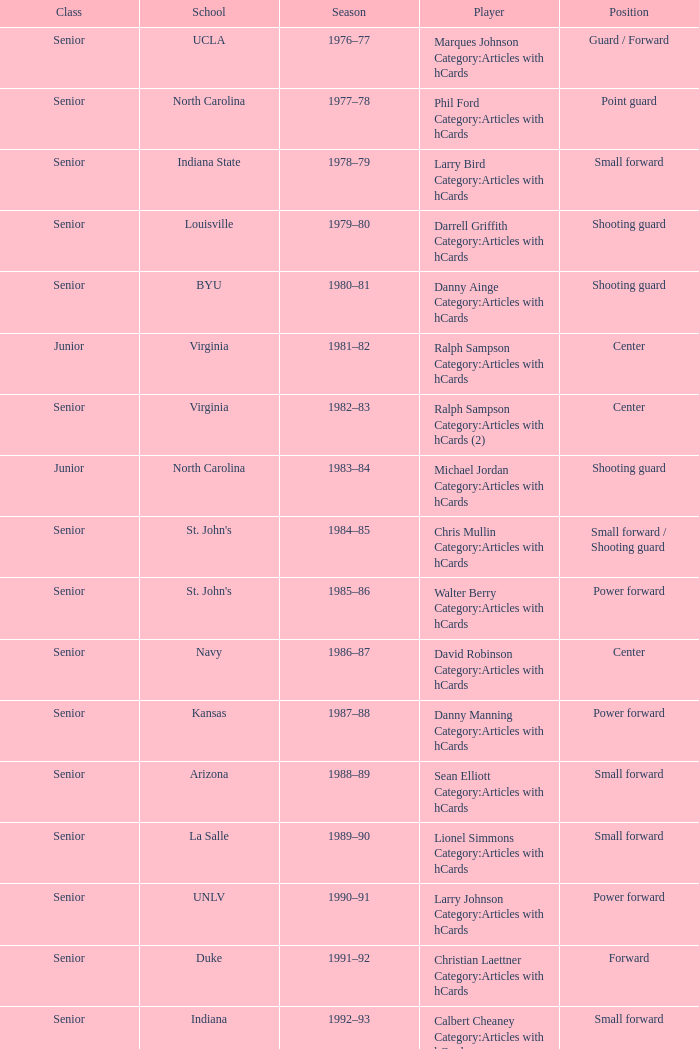Can you parse all the data within this table? {'header': ['Class', 'School', 'Season', 'Player', 'Position'], 'rows': [['Senior', 'UCLA', '1976–77', 'Marques Johnson Category:Articles with hCards', 'Guard / Forward'], ['Senior', 'North Carolina', '1977–78', 'Phil Ford Category:Articles with hCards', 'Point guard'], ['Senior', 'Indiana State', '1978–79', 'Larry Bird Category:Articles with hCards', 'Small forward'], ['Senior', 'Louisville', '1979–80', 'Darrell Griffith Category:Articles with hCards', 'Shooting guard'], ['Senior', 'BYU', '1980–81', 'Danny Ainge Category:Articles with hCards', 'Shooting guard'], ['Junior', 'Virginia', '1981–82', 'Ralph Sampson Category:Articles with hCards', 'Center'], ['Senior', 'Virginia', '1982–83', 'Ralph Sampson Category:Articles with hCards (2)', 'Center'], ['Junior', 'North Carolina', '1983–84', 'Michael Jordan Category:Articles with hCards', 'Shooting guard'], ['Senior', "St. John's", '1984–85', 'Chris Mullin Category:Articles with hCards', 'Small forward / Shooting guard'], ['Senior', "St. John's", '1985–86', 'Walter Berry Category:Articles with hCards', 'Power forward'], ['Senior', 'Navy', '1986–87', 'David Robinson Category:Articles with hCards', 'Center'], ['Senior', 'Kansas', '1987–88', 'Danny Manning Category:Articles with hCards', 'Power forward'], ['Senior', 'Arizona', '1988–89', 'Sean Elliott Category:Articles with hCards', 'Small forward'], ['Senior', 'La Salle', '1989–90', 'Lionel Simmons Category:Articles with hCards', 'Small forward'], ['Senior', 'UNLV', '1990–91', 'Larry Johnson Category:Articles with hCards', 'Power forward'], ['Senior', 'Duke', '1991–92', 'Christian Laettner Category:Articles with hCards', 'Forward'], ['Senior', 'Indiana', '1992–93', 'Calbert Cheaney Category:Articles with hCards', 'Small forward'], ['Sophomore', 'Purdue', '1993–94', 'Glenn Robinson Category:Articles with hCards', 'Small forward / Power forward'], ['Senior', 'UCLA', '1994–95', "Ed O'Bannon", 'Small forward'], ['Junior', 'Massachusetts', '1995–96', 'Marcus Camby Category:Articles with hCards', 'Center'], ['Senior', 'Wake Forest', '1996–97', 'Tim Duncan Category:Articles with hCards', 'Center'], ['Junior', 'North Carolina', '1997–98', 'Antawn Jamison Category:Articles with hCards', 'Small forward'], ['Sophomore', 'Duke', '1998–99', 'Elton Brand Category:Articles with hCards', 'Center'], ['Senior', 'Cincinnati', '1999–00', 'Kenyon Martin Category:Articles with hCards', 'Power forward'], ['Senior', 'Duke', '2000–01', 'Shane Battier Category:Articles with hCards', 'Small forward / Power forward'], ['Junior', 'Duke', '2001–02', 'Jay Williams Category:Articles with hCards', 'Point guard'], ['Sophomore', 'Texas', '2002–03', 'T. J. Ford Category:Articles with hCards', 'Point guard'], ['Senior', "Saint Joseph's", '2003–04', 'Jameer Nelson Category:Articles with hCards', 'Point guard'], ['Sophomore', 'Utah', '2004–05', 'Andrew Bogut Category:Articles with hCards', 'Center'], ['Senior', 'Duke', '2005–06', 'J. J. Redick Category:Articles with hCards', 'Shooting guard'], ['Freshman', 'Texas', '2006–07', 'Kevin Durant Category:Articles with hCards', 'Small forward'], ['Junior', 'North Carolina', '2007–08', 'Tyler Hansbrough Category:Articles with hCards', 'Power forward'], ['Sophomore', 'Oklahoma', '2008–09', 'Blake Griffin Category:Articles with hCards', 'Power forward'], ['Junior', 'Ohio State', '2009–10', 'Evan Turner Category:Articles with hCards', 'Small forward'], ['Senior', 'BYU', '2010–11', 'Jimmer Fredette Category:Articles with hCards', 'Point guard'], ['Freshman', 'Kentucky', '2011–12', 'Anthony Davis Category:Articles with hCards', 'Center'], ['Sophomore', 'Michigan', '2012–13', 'Trey Burke Category:Articles with hCards', 'Point guard']]} Name the position for indiana state Small forward. 